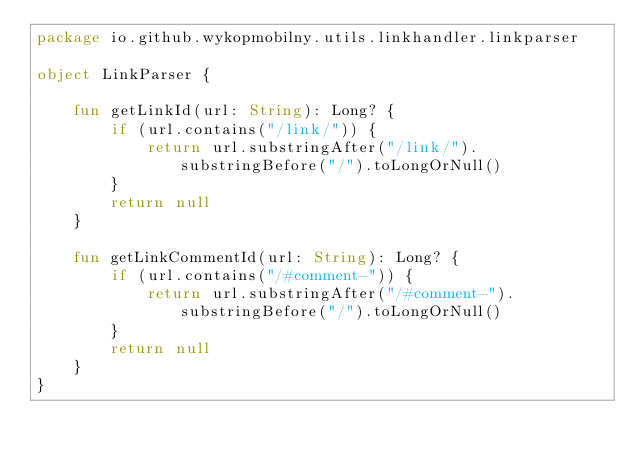Convert code to text. <code><loc_0><loc_0><loc_500><loc_500><_Kotlin_>package io.github.wykopmobilny.utils.linkhandler.linkparser

object LinkParser {

    fun getLinkId(url: String): Long? {
        if (url.contains("/link/")) {
            return url.substringAfter("/link/").substringBefore("/").toLongOrNull()
        }
        return null
    }

    fun getLinkCommentId(url: String): Long? {
        if (url.contains("/#comment-")) {
            return url.substringAfter("/#comment-").substringBefore("/").toLongOrNull()
        }
        return null
    }
}
</code> 